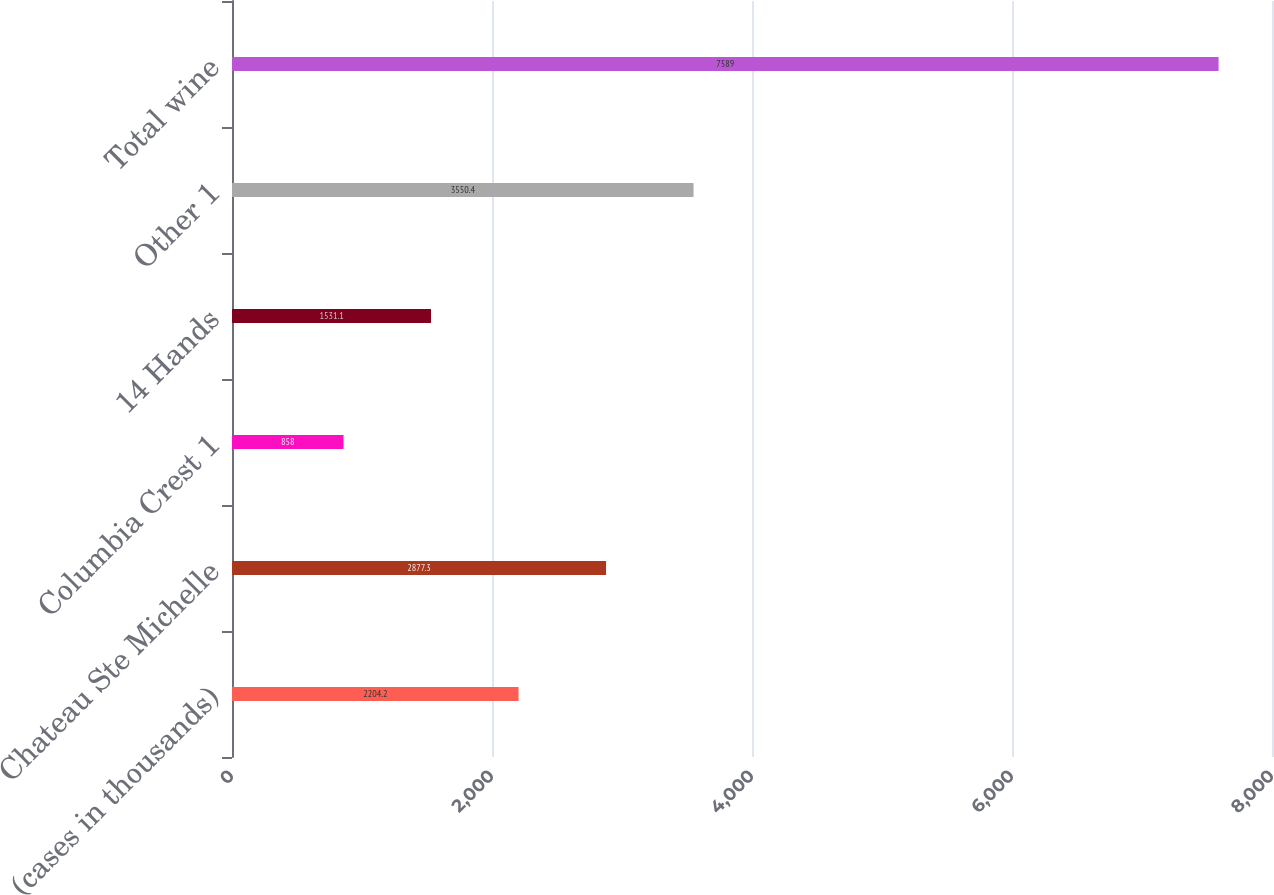Convert chart to OTSL. <chart><loc_0><loc_0><loc_500><loc_500><bar_chart><fcel>(cases in thousands)<fcel>Chateau Ste Michelle<fcel>Columbia Crest 1<fcel>14 Hands<fcel>Other 1<fcel>Total wine<nl><fcel>2204.2<fcel>2877.3<fcel>858<fcel>1531.1<fcel>3550.4<fcel>7589<nl></chart> 